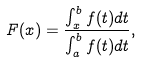Convert formula to latex. <formula><loc_0><loc_0><loc_500><loc_500>F ( x ) = \frac { \int _ { x } ^ { b } f ( t ) d t } { \int _ { a } ^ { b } f ( t ) d t } ,</formula> 